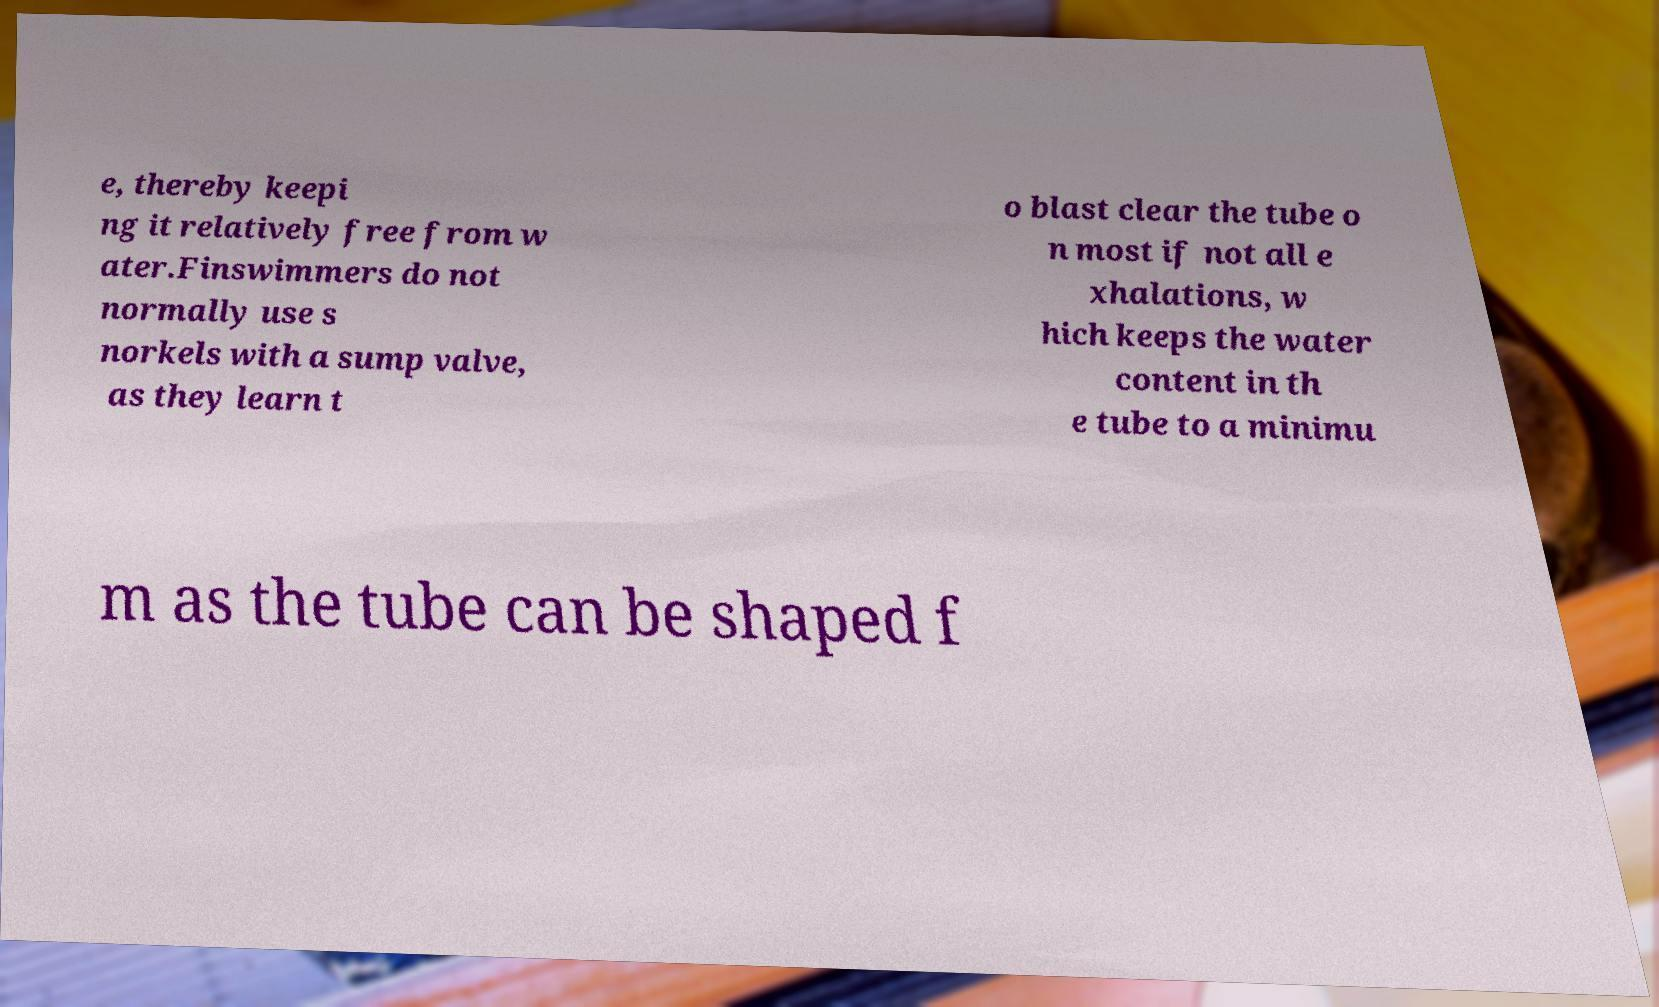I need the written content from this picture converted into text. Can you do that? e, thereby keepi ng it relatively free from w ater.Finswimmers do not normally use s norkels with a sump valve, as they learn t o blast clear the tube o n most if not all e xhalations, w hich keeps the water content in th e tube to a minimu m as the tube can be shaped f 